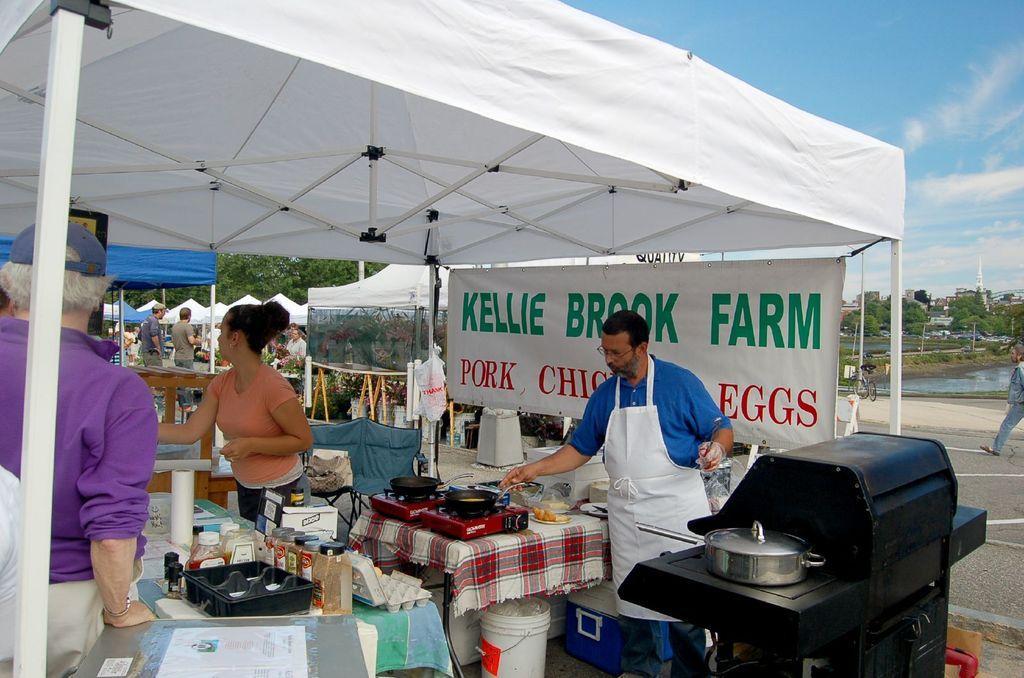Please provide a concise description of this image. In this image we can see a stall. There are tables on which there are objects. There are persons. In the background of the image there are other stalls. There are trees. To the right side of the image there is road. At the top of the image there is sky. 